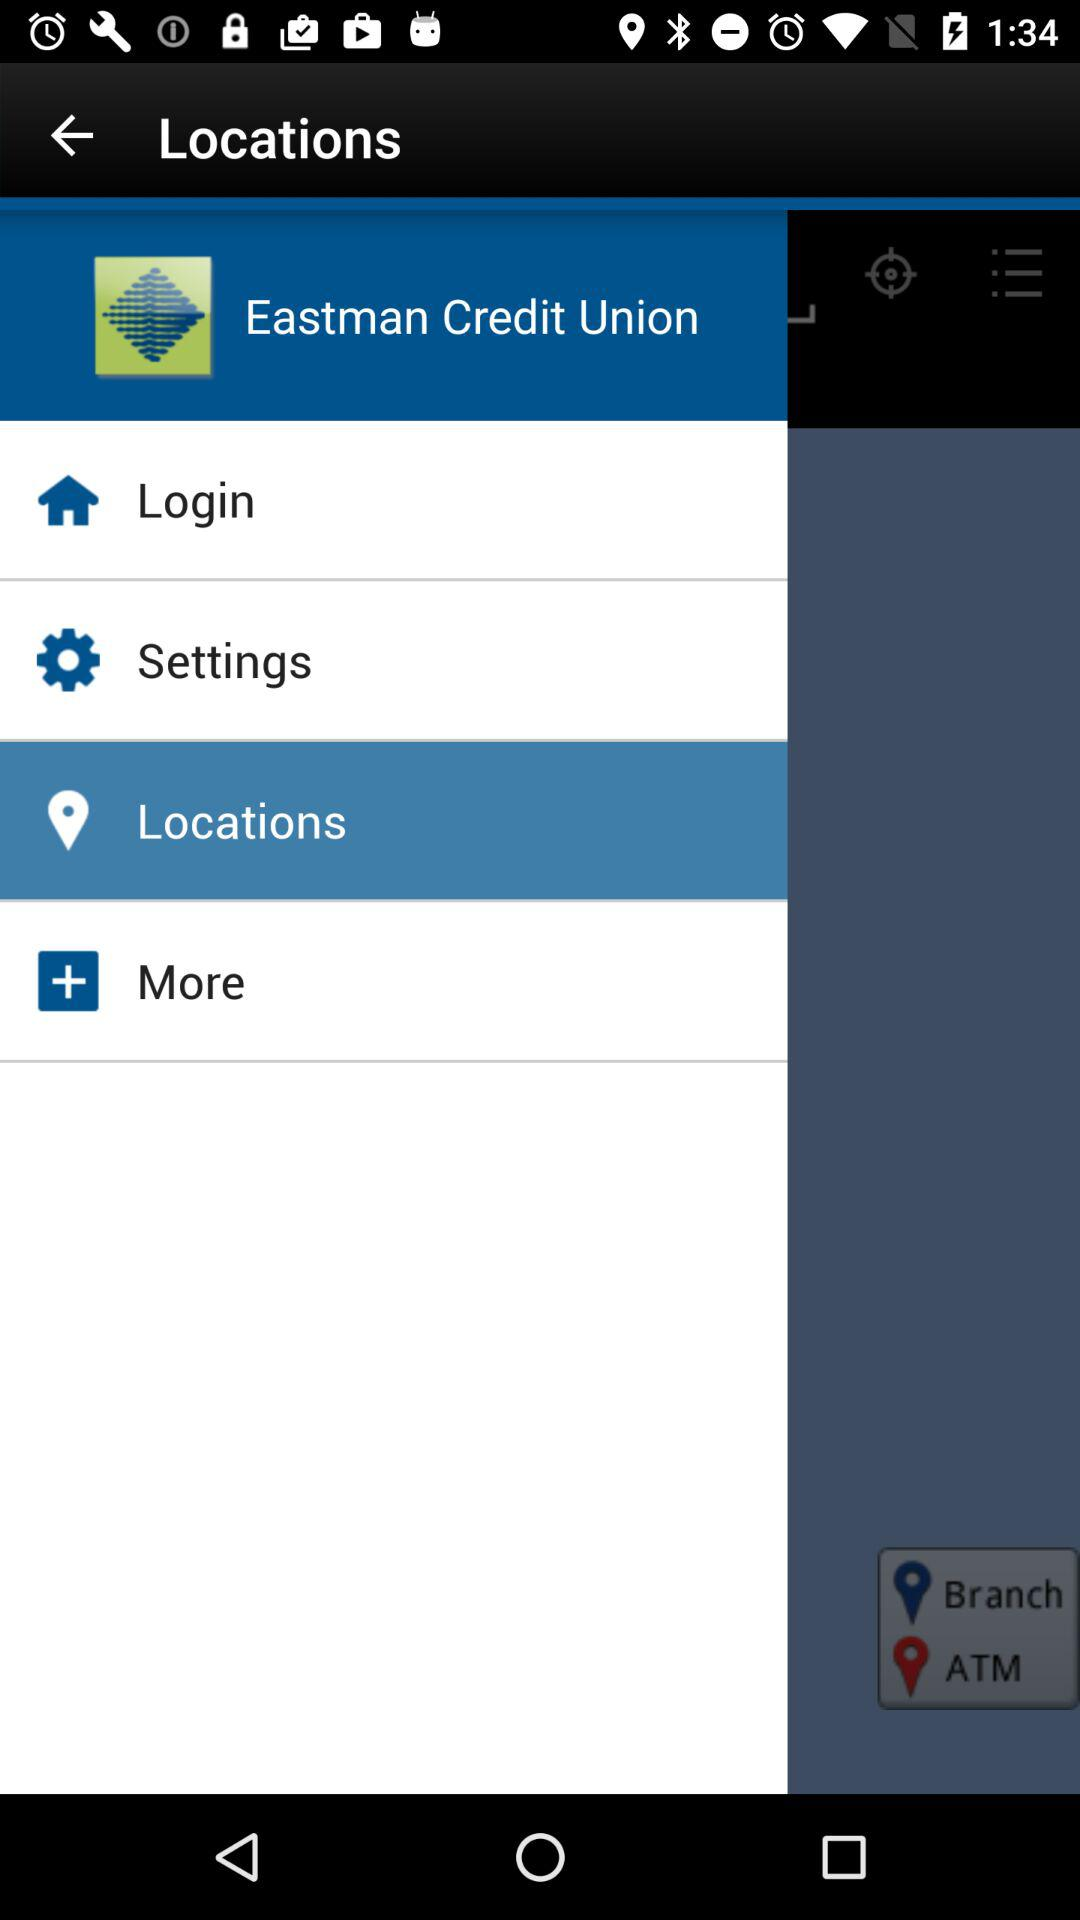What is the name of the application? The name of the application is "Eastern Credit Union". 